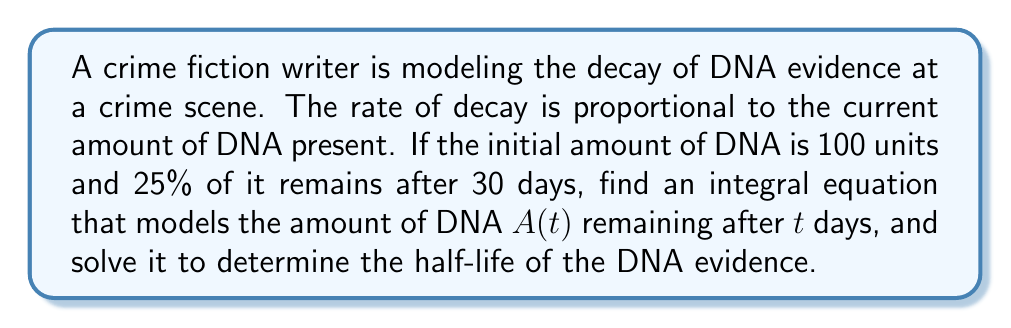Could you help me with this problem? Let's approach this step-by-step:

1) The rate of decay is proportional to the current amount, so we can write:

   $$\frac{dA}{dt} = -kA$$

   where $k$ is the decay constant.

2) This is a separable differential equation. We can rewrite it as:

   $$\frac{dA}{A} = -k dt$$

3) Integrating both sides:

   $$\int \frac{dA}{A} = -\int k dt$$

4) This gives us:

   $$\ln|A| = -kt + C$$

5) Taking the exponential of both sides:

   $$A = e^{-kt + C} = e^C e^{-kt}$$

6) Let $A_0 = e^C$ be the initial amount. Then our solution is:

   $$A(t) = A_0 e^{-kt}$$

7) We're given that $A_0 = 100$ and $A(30) = 25$ (25% of 100). Substituting:

   $$25 = 100 e^{-30k}$$

8) Solving for $k$:

   $$e^{-30k} = 0.25$$
   $$-30k = \ln(0.25)$$
   $$k = -\frac{\ln(0.25)}{30} \approx 0.0462$$

9) Now, to find the half-life $t_{1/2}$, we use:

   $$50 = 100 e^{-0.0462t_{1/2}}$$

10) Solving this:

    $$0.5 = e^{-0.0462t_{1/2}}$$
    $$\ln(0.5) = -0.0462t_{1/2}$$
    $$t_{1/2} = \frac{\ln(0.5)}{-0.0462} \approx 15$$

Therefore, the half-life is approximately 15 days.
Answer: $A(t) = 100e^{-0.0462t}$; Half-life ≈ 15 days 